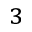<formula> <loc_0><loc_0><loc_500><loc_500>^ { 3 }</formula> 